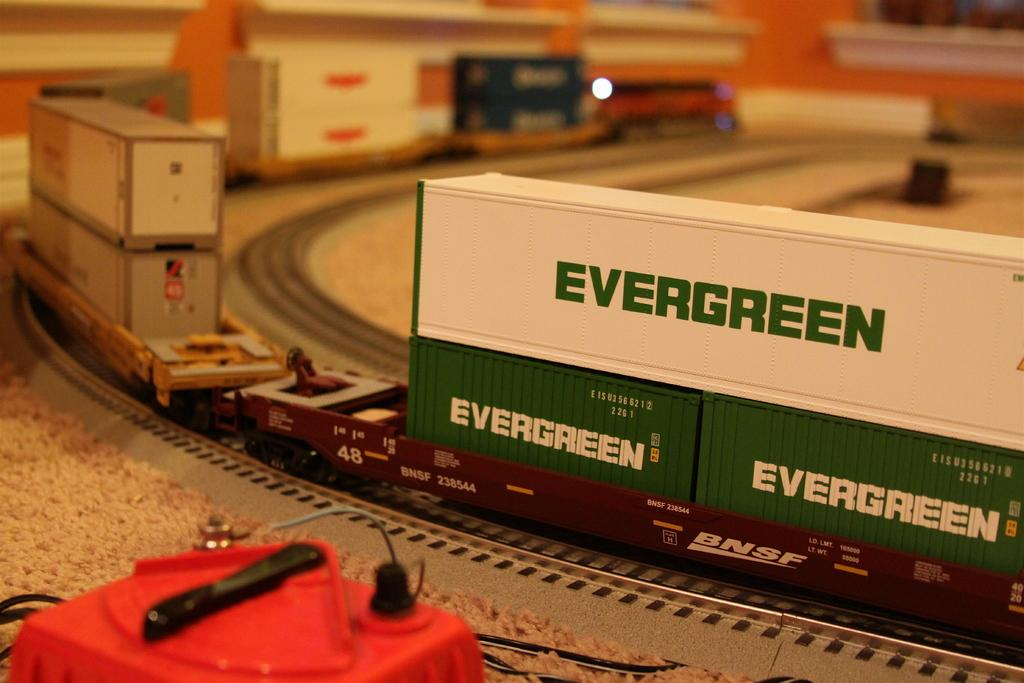Provide a one-sentence caption for the provided image. A model train carrying Evergreen cargo drives along a track. 